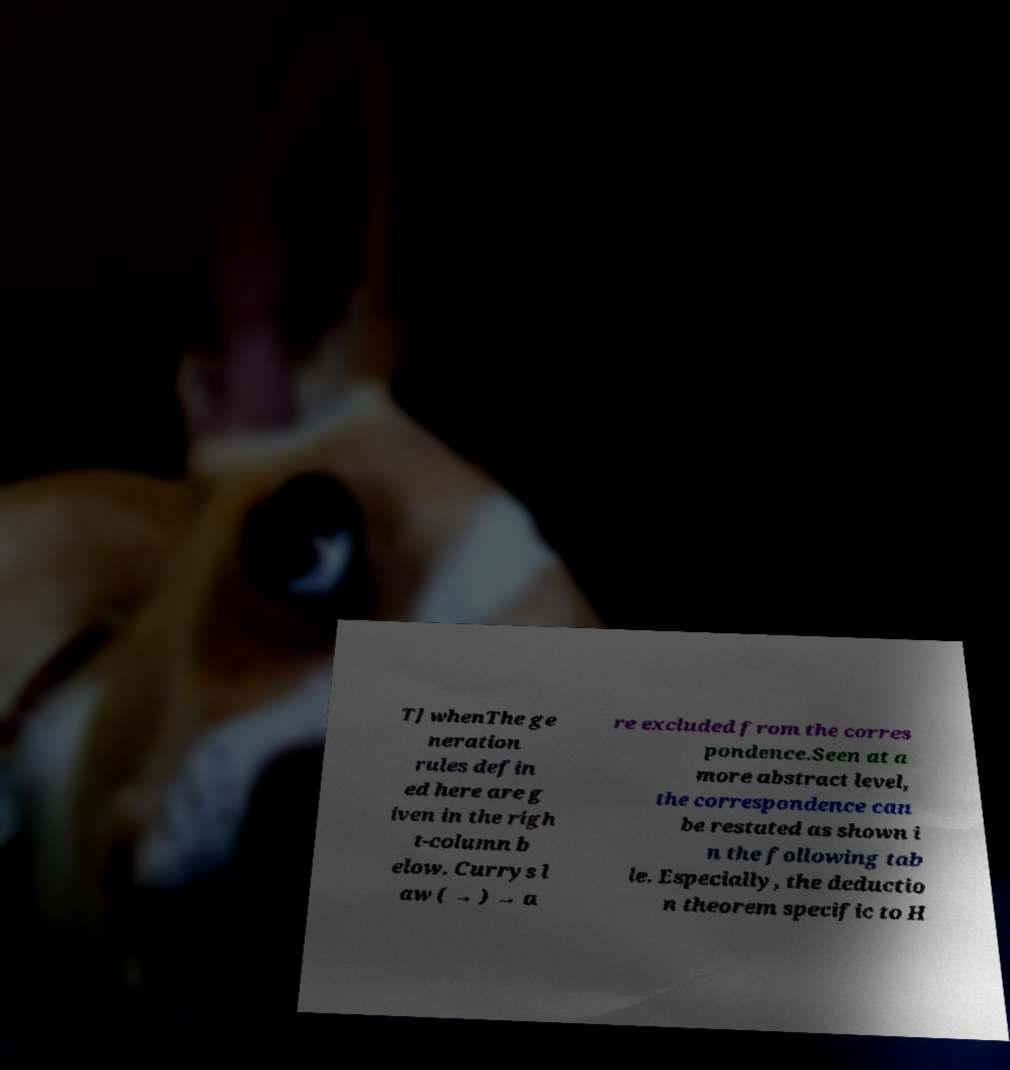Can you read and provide the text displayed in the image?This photo seems to have some interesting text. Can you extract and type it out for me? T] whenThe ge neration rules defin ed here are g iven in the righ t-column b elow. Currys l aw ( → ) → a re excluded from the corres pondence.Seen at a more abstract level, the correspondence can be restated as shown i n the following tab le. Especially, the deductio n theorem specific to H 